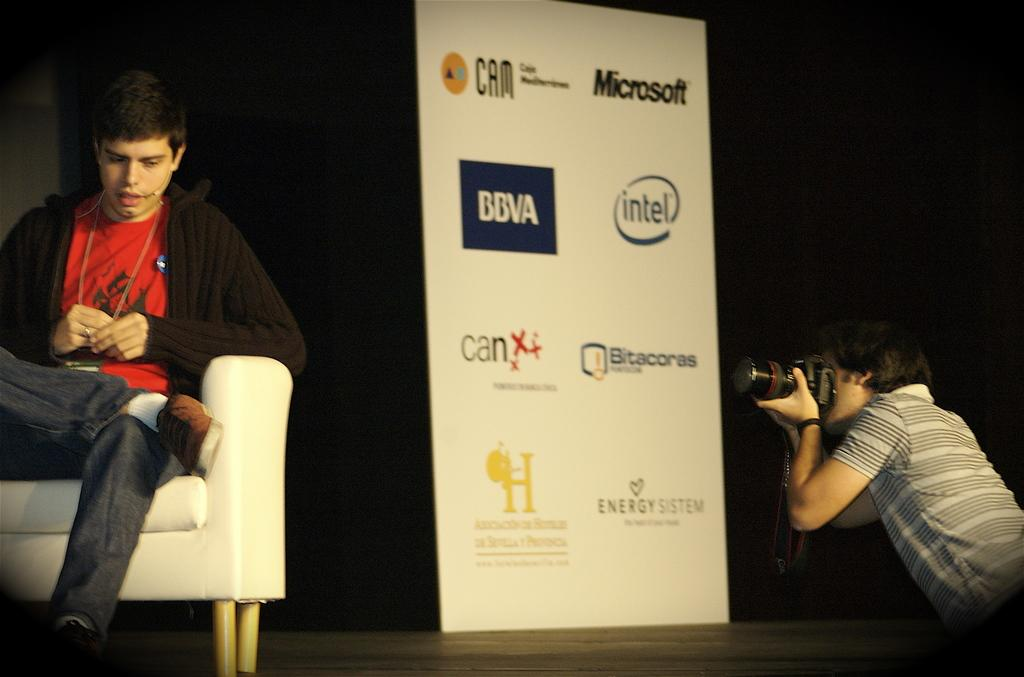What is the man on the left side of the image doing? There is a man sitting on the couch on the left side of the image. What is the man on the right side of the image holding? There is a man holding a camera on the right side of the image. What can be seen in the center of the image? There is a banner in the center of the image. How many pages are visible in the image? There are no pages present in the image. What unit of measurement is used to fold the banner in the image? The banner in the image is not being folded, so there is no unit of measurement involved. 